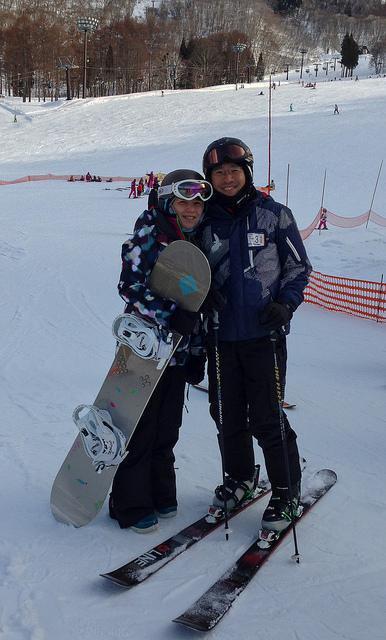How many googles are there?
Give a very brief answer. 2. How many people are there?
Give a very brief answer. 3. 